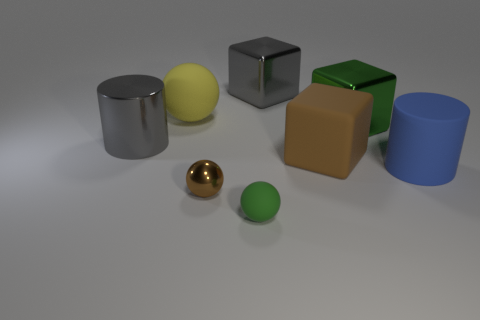What number of other objects are there of the same size as the yellow sphere?
Offer a very short reply. 5. There is a thing that is both behind the blue rubber thing and in front of the large gray cylinder; what is its size?
Make the answer very short. Large. What number of gray things are the same shape as the large brown object?
Ensure brevity in your answer.  1. What is the material of the big yellow thing?
Make the answer very short. Rubber. Is the shape of the yellow rubber thing the same as the blue rubber object?
Make the answer very short. No. Are there any large green things that have the same material as the brown block?
Give a very brief answer. No. There is a object that is both in front of the brown matte cube and on the right side of the large brown matte thing; what is its color?
Ensure brevity in your answer.  Blue. What is the material of the cylinder that is to the left of the big yellow matte thing?
Provide a succinct answer. Metal. Are there any small purple objects of the same shape as the green rubber thing?
Offer a terse response. No. How many other things are there of the same shape as the large green thing?
Ensure brevity in your answer.  2. 